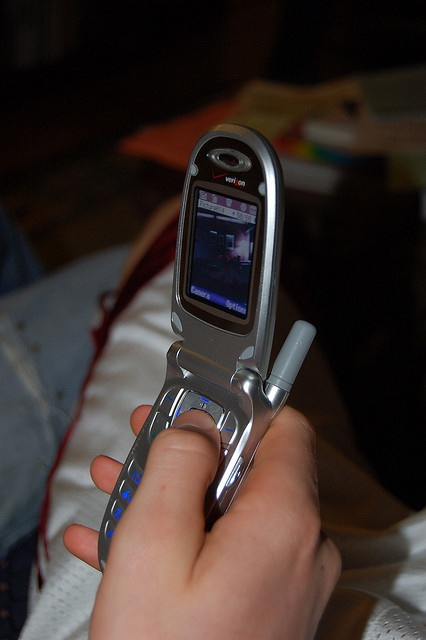Describe the objects in this image and their specific colors. I can see people in black, brown, salmon, and tan tones and cell phone in black, gray, and white tones in this image. 